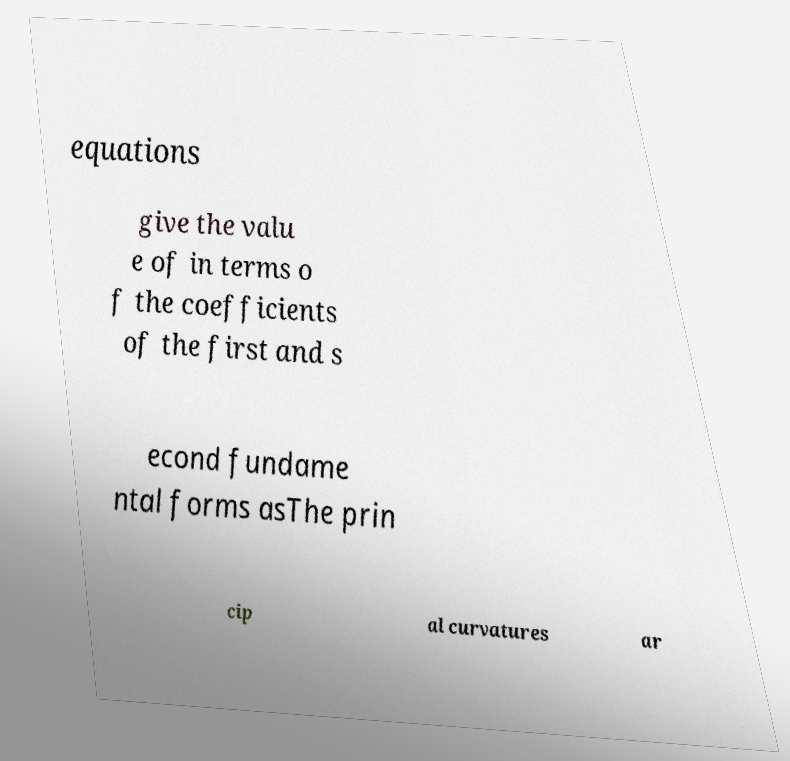Please identify and transcribe the text found in this image. equations give the valu e of in terms o f the coefficients of the first and s econd fundame ntal forms asThe prin cip al curvatures ar 